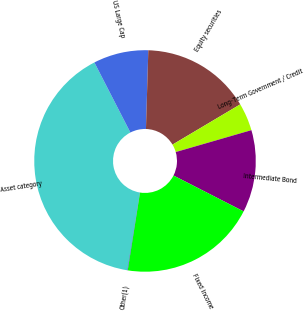<chart> <loc_0><loc_0><loc_500><loc_500><pie_chart><fcel>Asset category<fcel>US Large Cap<fcel>Equity securities<fcel>Long-Term Government / Credit<fcel>Intermediate Bond<fcel>Fixed income<fcel>Other(1)<nl><fcel>39.88%<fcel>8.03%<fcel>15.99%<fcel>4.05%<fcel>12.01%<fcel>19.97%<fcel>0.07%<nl></chart> 